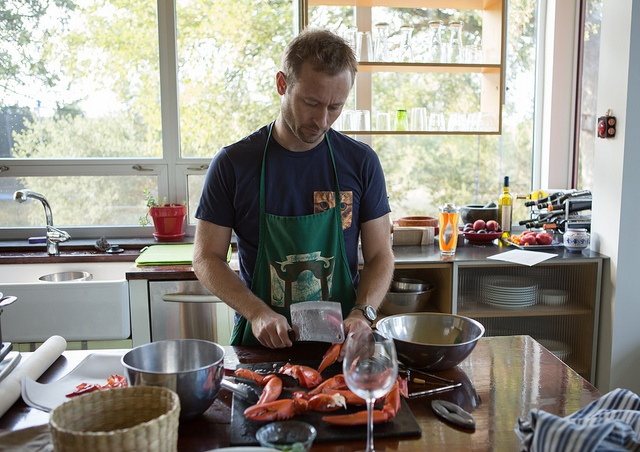Describe the objects in this image and their specific colors. I can see people in lightgray, black, gray, and maroon tones, sink in lightgray, darkgray, and gray tones, bowl in lightgray, gray, black, maroon, and darkgray tones, bowl in lightgray, gray, black, and darkgray tones, and bowl in lightgray, black, and gray tones in this image. 